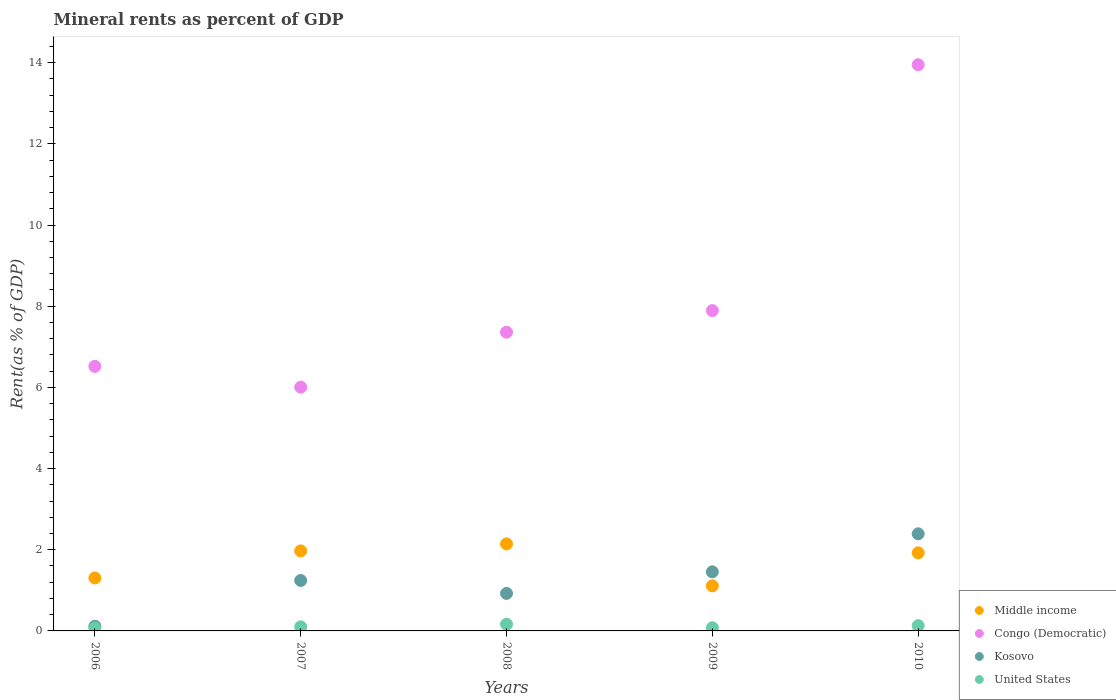What is the mineral rent in Middle income in 2007?
Ensure brevity in your answer.  1.97. Across all years, what is the maximum mineral rent in Kosovo?
Offer a very short reply. 2.39. Across all years, what is the minimum mineral rent in Middle income?
Make the answer very short. 1.11. In which year was the mineral rent in Kosovo minimum?
Provide a succinct answer. 2006. What is the total mineral rent in Kosovo in the graph?
Offer a very short reply. 6.13. What is the difference between the mineral rent in United States in 2007 and that in 2009?
Offer a terse response. 0.02. What is the difference between the mineral rent in Kosovo in 2006 and the mineral rent in Middle income in 2010?
Your response must be concise. -1.81. What is the average mineral rent in Congo (Democratic) per year?
Ensure brevity in your answer.  8.34. In the year 2006, what is the difference between the mineral rent in Congo (Democratic) and mineral rent in Middle income?
Your response must be concise. 5.21. In how many years, is the mineral rent in United States greater than 2.4 %?
Your answer should be compact. 0. What is the ratio of the mineral rent in Congo (Democratic) in 2006 to that in 2007?
Keep it short and to the point. 1.09. What is the difference between the highest and the second highest mineral rent in Kosovo?
Ensure brevity in your answer.  0.94. What is the difference between the highest and the lowest mineral rent in United States?
Offer a terse response. 0.09. In how many years, is the mineral rent in Congo (Democratic) greater than the average mineral rent in Congo (Democratic) taken over all years?
Keep it short and to the point. 1. Is the sum of the mineral rent in Congo (Democratic) in 2006 and 2010 greater than the maximum mineral rent in United States across all years?
Offer a terse response. Yes. Is it the case that in every year, the sum of the mineral rent in Congo (Democratic) and mineral rent in Kosovo  is greater than the sum of mineral rent in United States and mineral rent in Middle income?
Your response must be concise. Yes. Is it the case that in every year, the sum of the mineral rent in Kosovo and mineral rent in United States  is greater than the mineral rent in Congo (Democratic)?
Provide a short and direct response. No. Is the mineral rent in United States strictly greater than the mineral rent in Middle income over the years?
Keep it short and to the point. No. How many years are there in the graph?
Your response must be concise. 5. What is the difference between two consecutive major ticks on the Y-axis?
Ensure brevity in your answer.  2. Where does the legend appear in the graph?
Your answer should be very brief. Bottom right. How are the legend labels stacked?
Make the answer very short. Vertical. What is the title of the graph?
Give a very brief answer. Mineral rents as percent of GDP. Does "Madagascar" appear as one of the legend labels in the graph?
Provide a succinct answer. No. What is the label or title of the Y-axis?
Make the answer very short. Rent(as % of GDP). What is the Rent(as % of GDP) of Middle income in 2006?
Give a very brief answer. 1.31. What is the Rent(as % of GDP) in Congo (Democratic) in 2006?
Give a very brief answer. 6.52. What is the Rent(as % of GDP) of Kosovo in 2006?
Your answer should be compact. 0.12. What is the Rent(as % of GDP) in United States in 2006?
Keep it short and to the point. 0.07. What is the Rent(as % of GDP) in Middle income in 2007?
Offer a very short reply. 1.97. What is the Rent(as % of GDP) in Congo (Democratic) in 2007?
Provide a short and direct response. 6.01. What is the Rent(as % of GDP) in Kosovo in 2007?
Provide a short and direct response. 1.24. What is the Rent(as % of GDP) in United States in 2007?
Make the answer very short. 0.1. What is the Rent(as % of GDP) in Middle income in 2008?
Provide a short and direct response. 2.14. What is the Rent(as % of GDP) in Congo (Democratic) in 2008?
Keep it short and to the point. 7.36. What is the Rent(as % of GDP) in Kosovo in 2008?
Provide a succinct answer. 0.92. What is the Rent(as % of GDP) in United States in 2008?
Your answer should be compact. 0.17. What is the Rent(as % of GDP) in Middle income in 2009?
Your answer should be very brief. 1.11. What is the Rent(as % of GDP) in Congo (Democratic) in 2009?
Keep it short and to the point. 7.89. What is the Rent(as % of GDP) of Kosovo in 2009?
Your answer should be very brief. 1.46. What is the Rent(as % of GDP) in United States in 2009?
Offer a terse response. 0.08. What is the Rent(as % of GDP) of Middle income in 2010?
Ensure brevity in your answer.  1.92. What is the Rent(as % of GDP) in Congo (Democratic) in 2010?
Your answer should be compact. 13.95. What is the Rent(as % of GDP) of Kosovo in 2010?
Provide a short and direct response. 2.39. What is the Rent(as % of GDP) of United States in 2010?
Offer a terse response. 0.13. Across all years, what is the maximum Rent(as % of GDP) in Middle income?
Give a very brief answer. 2.14. Across all years, what is the maximum Rent(as % of GDP) of Congo (Democratic)?
Your answer should be compact. 13.95. Across all years, what is the maximum Rent(as % of GDP) in Kosovo?
Provide a succinct answer. 2.39. Across all years, what is the maximum Rent(as % of GDP) in United States?
Keep it short and to the point. 0.17. Across all years, what is the minimum Rent(as % of GDP) of Middle income?
Offer a very short reply. 1.11. Across all years, what is the minimum Rent(as % of GDP) in Congo (Democratic)?
Offer a terse response. 6.01. Across all years, what is the minimum Rent(as % of GDP) of Kosovo?
Offer a very short reply. 0.12. Across all years, what is the minimum Rent(as % of GDP) in United States?
Provide a succinct answer. 0.07. What is the total Rent(as % of GDP) of Middle income in the graph?
Provide a short and direct response. 8.46. What is the total Rent(as % of GDP) in Congo (Democratic) in the graph?
Give a very brief answer. 41.72. What is the total Rent(as % of GDP) in Kosovo in the graph?
Provide a succinct answer. 6.13. What is the total Rent(as % of GDP) in United States in the graph?
Provide a succinct answer. 0.55. What is the difference between the Rent(as % of GDP) in Middle income in 2006 and that in 2007?
Keep it short and to the point. -0.67. What is the difference between the Rent(as % of GDP) of Congo (Democratic) in 2006 and that in 2007?
Ensure brevity in your answer.  0.51. What is the difference between the Rent(as % of GDP) in Kosovo in 2006 and that in 2007?
Ensure brevity in your answer.  -1.13. What is the difference between the Rent(as % of GDP) in United States in 2006 and that in 2007?
Offer a very short reply. -0.03. What is the difference between the Rent(as % of GDP) in Middle income in 2006 and that in 2008?
Provide a short and direct response. -0.84. What is the difference between the Rent(as % of GDP) in Congo (Democratic) in 2006 and that in 2008?
Your response must be concise. -0.84. What is the difference between the Rent(as % of GDP) of Kosovo in 2006 and that in 2008?
Keep it short and to the point. -0.81. What is the difference between the Rent(as % of GDP) of United States in 2006 and that in 2008?
Make the answer very short. -0.09. What is the difference between the Rent(as % of GDP) in Middle income in 2006 and that in 2009?
Provide a short and direct response. 0.19. What is the difference between the Rent(as % of GDP) in Congo (Democratic) in 2006 and that in 2009?
Keep it short and to the point. -1.37. What is the difference between the Rent(as % of GDP) in Kosovo in 2006 and that in 2009?
Provide a succinct answer. -1.34. What is the difference between the Rent(as % of GDP) of United States in 2006 and that in 2009?
Your answer should be very brief. -0.01. What is the difference between the Rent(as % of GDP) of Middle income in 2006 and that in 2010?
Ensure brevity in your answer.  -0.62. What is the difference between the Rent(as % of GDP) of Congo (Democratic) in 2006 and that in 2010?
Your response must be concise. -7.43. What is the difference between the Rent(as % of GDP) of Kosovo in 2006 and that in 2010?
Your response must be concise. -2.28. What is the difference between the Rent(as % of GDP) in United States in 2006 and that in 2010?
Provide a short and direct response. -0.06. What is the difference between the Rent(as % of GDP) of Middle income in 2007 and that in 2008?
Offer a very short reply. -0.17. What is the difference between the Rent(as % of GDP) of Congo (Democratic) in 2007 and that in 2008?
Your answer should be compact. -1.35. What is the difference between the Rent(as % of GDP) of Kosovo in 2007 and that in 2008?
Keep it short and to the point. 0.32. What is the difference between the Rent(as % of GDP) in United States in 2007 and that in 2008?
Offer a very short reply. -0.06. What is the difference between the Rent(as % of GDP) of Middle income in 2007 and that in 2009?
Offer a terse response. 0.86. What is the difference between the Rent(as % of GDP) of Congo (Democratic) in 2007 and that in 2009?
Keep it short and to the point. -1.89. What is the difference between the Rent(as % of GDP) of Kosovo in 2007 and that in 2009?
Ensure brevity in your answer.  -0.21. What is the difference between the Rent(as % of GDP) in United States in 2007 and that in 2009?
Offer a very short reply. 0.02. What is the difference between the Rent(as % of GDP) of Middle income in 2007 and that in 2010?
Offer a terse response. 0.05. What is the difference between the Rent(as % of GDP) of Congo (Democratic) in 2007 and that in 2010?
Make the answer very short. -7.94. What is the difference between the Rent(as % of GDP) of Kosovo in 2007 and that in 2010?
Keep it short and to the point. -1.15. What is the difference between the Rent(as % of GDP) of United States in 2007 and that in 2010?
Your answer should be very brief. -0.03. What is the difference between the Rent(as % of GDP) of Middle income in 2008 and that in 2009?
Give a very brief answer. 1.03. What is the difference between the Rent(as % of GDP) in Congo (Democratic) in 2008 and that in 2009?
Offer a very short reply. -0.53. What is the difference between the Rent(as % of GDP) of Kosovo in 2008 and that in 2009?
Your response must be concise. -0.53. What is the difference between the Rent(as % of GDP) in United States in 2008 and that in 2009?
Your answer should be compact. 0.09. What is the difference between the Rent(as % of GDP) in Middle income in 2008 and that in 2010?
Make the answer very short. 0.22. What is the difference between the Rent(as % of GDP) of Congo (Democratic) in 2008 and that in 2010?
Your answer should be very brief. -6.59. What is the difference between the Rent(as % of GDP) of Kosovo in 2008 and that in 2010?
Your response must be concise. -1.47. What is the difference between the Rent(as % of GDP) of United States in 2008 and that in 2010?
Provide a succinct answer. 0.04. What is the difference between the Rent(as % of GDP) in Middle income in 2009 and that in 2010?
Provide a succinct answer. -0.81. What is the difference between the Rent(as % of GDP) in Congo (Democratic) in 2009 and that in 2010?
Your response must be concise. -6.06. What is the difference between the Rent(as % of GDP) in Kosovo in 2009 and that in 2010?
Ensure brevity in your answer.  -0.94. What is the difference between the Rent(as % of GDP) in United States in 2009 and that in 2010?
Ensure brevity in your answer.  -0.05. What is the difference between the Rent(as % of GDP) of Middle income in 2006 and the Rent(as % of GDP) of Congo (Democratic) in 2007?
Keep it short and to the point. -4.7. What is the difference between the Rent(as % of GDP) in Middle income in 2006 and the Rent(as % of GDP) in Kosovo in 2007?
Provide a short and direct response. 0.06. What is the difference between the Rent(as % of GDP) in Middle income in 2006 and the Rent(as % of GDP) in United States in 2007?
Offer a terse response. 1.2. What is the difference between the Rent(as % of GDP) of Congo (Democratic) in 2006 and the Rent(as % of GDP) of Kosovo in 2007?
Provide a short and direct response. 5.27. What is the difference between the Rent(as % of GDP) of Congo (Democratic) in 2006 and the Rent(as % of GDP) of United States in 2007?
Keep it short and to the point. 6.42. What is the difference between the Rent(as % of GDP) of Kosovo in 2006 and the Rent(as % of GDP) of United States in 2007?
Make the answer very short. 0.02. What is the difference between the Rent(as % of GDP) of Middle income in 2006 and the Rent(as % of GDP) of Congo (Democratic) in 2008?
Provide a short and direct response. -6.05. What is the difference between the Rent(as % of GDP) in Middle income in 2006 and the Rent(as % of GDP) in Kosovo in 2008?
Offer a very short reply. 0.38. What is the difference between the Rent(as % of GDP) of Middle income in 2006 and the Rent(as % of GDP) of United States in 2008?
Your answer should be very brief. 1.14. What is the difference between the Rent(as % of GDP) of Congo (Democratic) in 2006 and the Rent(as % of GDP) of Kosovo in 2008?
Give a very brief answer. 5.59. What is the difference between the Rent(as % of GDP) in Congo (Democratic) in 2006 and the Rent(as % of GDP) in United States in 2008?
Provide a succinct answer. 6.35. What is the difference between the Rent(as % of GDP) in Kosovo in 2006 and the Rent(as % of GDP) in United States in 2008?
Offer a terse response. -0.05. What is the difference between the Rent(as % of GDP) of Middle income in 2006 and the Rent(as % of GDP) of Congo (Democratic) in 2009?
Your answer should be very brief. -6.59. What is the difference between the Rent(as % of GDP) in Middle income in 2006 and the Rent(as % of GDP) in Kosovo in 2009?
Offer a terse response. -0.15. What is the difference between the Rent(as % of GDP) in Middle income in 2006 and the Rent(as % of GDP) in United States in 2009?
Your answer should be compact. 1.23. What is the difference between the Rent(as % of GDP) in Congo (Democratic) in 2006 and the Rent(as % of GDP) in Kosovo in 2009?
Keep it short and to the point. 5.06. What is the difference between the Rent(as % of GDP) of Congo (Democratic) in 2006 and the Rent(as % of GDP) of United States in 2009?
Make the answer very short. 6.44. What is the difference between the Rent(as % of GDP) in Kosovo in 2006 and the Rent(as % of GDP) in United States in 2009?
Keep it short and to the point. 0.04. What is the difference between the Rent(as % of GDP) in Middle income in 2006 and the Rent(as % of GDP) in Congo (Democratic) in 2010?
Provide a short and direct response. -12.64. What is the difference between the Rent(as % of GDP) in Middle income in 2006 and the Rent(as % of GDP) in Kosovo in 2010?
Give a very brief answer. -1.09. What is the difference between the Rent(as % of GDP) of Middle income in 2006 and the Rent(as % of GDP) of United States in 2010?
Give a very brief answer. 1.18. What is the difference between the Rent(as % of GDP) in Congo (Democratic) in 2006 and the Rent(as % of GDP) in Kosovo in 2010?
Offer a terse response. 4.12. What is the difference between the Rent(as % of GDP) in Congo (Democratic) in 2006 and the Rent(as % of GDP) in United States in 2010?
Offer a terse response. 6.39. What is the difference between the Rent(as % of GDP) in Kosovo in 2006 and the Rent(as % of GDP) in United States in 2010?
Make the answer very short. -0.01. What is the difference between the Rent(as % of GDP) in Middle income in 2007 and the Rent(as % of GDP) in Congo (Democratic) in 2008?
Make the answer very short. -5.39. What is the difference between the Rent(as % of GDP) in Middle income in 2007 and the Rent(as % of GDP) in Kosovo in 2008?
Your response must be concise. 1.05. What is the difference between the Rent(as % of GDP) of Middle income in 2007 and the Rent(as % of GDP) of United States in 2008?
Ensure brevity in your answer.  1.81. What is the difference between the Rent(as % of GDP) in Congo (Democratic) in 2007 and the Rent(as % of GDP) in Kosovo in 2008?
Provide a short and direct response. 5.08. What is the difference between the Rent(as % of GDP) in Congo (Democratic) in 2007 and the Rent(as % of GDP) in United States in 2008?
Offer a terse response. 5.84. What is the difference between the Rent(as % of GDP) of Kosovo in 2007 and the Rent(as % of GDP) of United States in 2008?
Give a very brief answer. 1.08. What is the difference between the Rent(as % of GDP) in Middle income in 2007 and the Rent(as % of GDP) in Congo (Democratic) in 2009?
Offer a very short reply. -5.92. What is the difference between the Rent(as % of GDP) in Middle income in 2007 and the Rent(as % of GDP) in Kosovo in 2009?
Offer a terse response. 0.52. What is the difference between the Rent(as % of GDP) of Middle income in 2007 and the Rent(as % of GDP) of United States in 2009?
Your response must be concise. 1.89. What is the difference between the Rent(as % of GDP) of Congo (Democratic) in 2007 and the Rent(as % of GDP) of Kosovo in 2009?
Offer a very short reply. 4.55. What is the difference between the Rent(as % of GDP) in Congo (Democratic) in 2007 and the Rent(as % of GDP) in United States in 2009?
Your answer should be compact. 5.93. What is the difference between the Rent(as % of GDP) of Kosovo in 2007 and the Rent(as % of GDP) of United States in 2009?
Ensure brevity in your answer.  1.16. What is the difference between the Rent(as % of GDP) in Middle income in 2007 and the Rent(as % of GDP) in Congo (Democratic) in 2010?
Your answer should be very brief. -11.98. What is the difference between the Rent(as % of GDP) of Middle income in 2007 and the Rent(as % of GDP) of Kosovo in 2010?
Offer a terse response. -0.42. What is the difference between the Rent(as % of GDP) of Middle income in 2007 and the Rent(as % of GDP) of United States in 2010?
Offer a very short reply. 1.84. What is the difference between the Rent(as % of GDP) of Congo (Democratic) in 2007 and the Rent(as % of GDP) of Kosovo in 2010?
Make the answer very short. 3.61. What is the difference between the Rent(as % of GDP) in Congo (Democratic) in 2007 and the Rent(as % of GDP) in United States in 2010?
Give a very brief answer. 5.88. What is the difference between the Rent(as % of GDP) of Kosovo in 2007 and the Rent(as % of GDP) of United States in 2010?
Offer a terse response. 1.11. What is the difference between the Rent(as % of GDP) of Middle income in 2008 and the Rent(as % of GDP) of Congo (Democratic) in 2009?
Make the answer very short. -5.75. What is the difference between the Rent(as % of GDP) in Middle income in 2008 and the Rent(as % of GDP) in Kosovo in 2009?
Offer a very short reply. 0.69. What is the difference between the Rent(as % of GDP) of Middle income in 2008 and the Rent(as % of GDP) of United States in 2009?
Provide a succinct answer. 2.07. What is the difference between the Rent(as % of GDP) of Congo (Democratic) in 2008 and the Rent(as % of GDP) of Kosovo in 2009?
Your answer should be compact. 5.9. What is the difference between the Rent(as % of GDP) of Congo (Democratic) in 2008 and the Rent(as % of GDP) of United States in 2009?
Offer a terse response. 7.28. What is the difference between the Rent(as % of GDP) in Kosovo in 2008 and the Rent(as % of GDP) in United States in 2009?
Provide a short and direct response. 0.85. What is the difference between the Rent(as % of GDP) of Middle income in 2008 and the Rent(as % of GDP) of Congo (Democratic) in 2010?
Your answer should be compact. -11.8. What is the difference between the Rent(as % of GDP) of Middle income in 2008 and the Rent(as % of GDP) of Kosovo in 2010?
Ensure brevity in your answer.  -0.25. What is the difference between the Rent(as % of GDP) of Middle income in 2008 and the Rent(as % of GDP) of United States in 2010?
Provide a succinct answer. 2.02. What is the difference between the Rent(as % of GDP) in Congo (Democratic) in 2008 and the Rent(as % of GDP) in Kosovo in 2010?
Offer a very short reply. 4.97. What is the difference between the Rent(as % of GDP) in Congo (Democratic) in 2008 and the Rent(as % of GDP) in United States in 2010?
Give a very brief answer. 7.23. What is the difference between the Rent(as % of GDP) of Kosovo in 2008 and the Rent(as % of GDP) of United States in 2010?
Give a very brief answer. 0.79. What is the difference between the Rent(as % of GDP) in Middle income in 2009 and the Rent(as % of GDP) in Congo (Democratic) in 2010?
Offer a very short reply. -12.84. What is the difference between the Rent(as % of GDP) in Middle income in 2009 and the Rent(as % of GDP) in Kosovo in 2010?
Provide a short and direct response. -1.28. What is the difference between the Rent(as % of GDP) in Middle income in 2009 and the Rent(as % of GDP) in United States in 2010?
Offer a very short reply. 0.98. What is the difference between the Rent(as % of GDP) in Congo (Democratic) in 2009 and the Rent(as % of GDP) in Kosovo in 2010?
Ensure brevity in your answer.  5.5. What is the difference between the Rent(as % of GDP) in Congo (Democratic) in 2009 and the Rent(as % of GDP) in United States in 2010?
Keep it short and to the point. 7.76. What is the difference between the Rent(as % of GDP) in Kosovo in 2009 and the Rent(as % of GDP) in United States in 2010?
Make the answer very short. 1.33. What is the average Rent(as % of GDP) of Middle income per year?
Provide a short and direct response. 1.69. What is the average Rent(as % of GDP) of Congo (Democratic) per year?
Your answer should be compact. 8.34. What is the average Rent(as % of GDP) of Kosovo per year?
Ensure brevity in your answer.  1.23. What is the average Rent(as % of GDP) in United States per year?
Your response must be concise. 0.11. In the year 2006, what is the difference between the Rent(as % of GDP) in Middle income and Rent(as % of GDP) in Congo (Democratic)?
Make the answer very short. -5.21. In the year 2006, what is the difference between the Rent(as % of GDP) of Middle income and Rent(as % of GDP) of Kosovo?
Keep it short and to the point. 1.19. In the year 2006, what is the difference between the Rent(as % of GDP) in Middle income and Rent(as % of GDP) in United States?
Your answer should be compact. 1.23. In the year 2006, what is the difference between the Rent(as % of GDP) of Congo (Democratic) and Rent(as % of GDP) of Kosovo?
Offer a very short reply. 6.4. In the year 2006, what is the difference between the Rent(as % of GDP) in Congo (Democratic) and Rent(as % of GDP) in United States?
Ensure brevity in your answer.  6.44. In the year 2006, what is the difference between the Rent(as % of GDP) of Kosovo and Rent(as % of GDP) of United States?
Offer a terse response. 0.04. In the year 2007, what is the difference between the Rent(as % of GDP) of Middle income and Rent(as % of GDP) of Congo (Democratic)?
Keep it short and to the point. -4.03. In the year 2007, what is the difference between the Rent(as % of GDP) of Middle income and Rent(as % of GDP) of Kosovo?
Make the answer very short. 0.73. In the year 2007, what is the difference between the Rent(as % of GDP) in Middle income and Rent(as % of GDP) in United States?
Provide a succinct answer. 1.87. In the year 2007, what is the difference between the Rent(as % of GDP) in Congo (Democratic) and Rent(as % of GDP) in Kosovo?
Your answer should be compact. 4.76. In the year 2007, what is the difference between the Rent(as % of GDP) in Congo (Democratic) and Rent(as % of GDP) in United States?
Provide a short and direct response. 5.9. In the year 2007, what is the difference between the Rent(as % of GDP) of Kosovo and Rent(as % of GDP) of United States?
Offer a very short reply. 1.14. In the year 2008, what is the difference between the Rent(as % of GDP) in Middle income and Rent(as % of GDP) in Congo (Democratic)?
Offer a very short reply. -5.21. In the year 2008, what is the difference between the Rent(as % of GDP) of Middle income and Rent(as % of GDP) of Kosovo?
Your answer should be compact. 1.22. In the year 2008, what is the difference between the Rent(as % of GDP) in Middle income and Rent(as % of GDP) in United States?
Offer a terse response. 1.98. In the year 2008, what is the difference between the Rent(as % of GDP) of Congo (Democratic) and Rent(as % of GDP) of Kosovo?
Offer a terse response. 6.44. In the year 2008, what is the difference between the Rent(as % of GDP) in Congo (Democratic) and Rent(as % of GDP) in United States?
Provide a short and direct response. 7.19. In the year 2008, what is the difference between the Rent(as % of GDP) in Kosovo and Rent(as % of GDP) in United States?
Provide a short and direct response. 0.76. In the year 2009, what is the difference between the Rent(as % of GDP) in Middle income and Rent(as % of GDP) in Congo (Democratic)?
Your answer should be very brief. -6.78. In the year 2009, what is the difference between the Rent(as % of GDP) of Middle income and Rent(as % of GDP) of Kosovo?
Your response must be concise. -0.34. In the year 2009, what is the difference between the Rent(as % of GDP) of Middle income and Rent(as % of GDP) of United States?
Give a very brief answer. 1.03. In the year 2009, what is the difference between the Rent(as % of GDP) of Congo (Democratic) and Rent(as % of GDP) of Kosovo?
Give a very brief answer. 6.44. In the year 2009, what is the difference between the Rent(as % of GDP) of Congo (Democratic) and Rent(as % of GDP) of United States?
Give a very brief answer. 7.81. In the year 2009, what is the difference between the Rent(as % of GDP) of Kosovo and Rent(as % of GDP) of United States?
Ensure brevity in your answer.  1.38. In the year 2010, what is the difference between the Rent(as % of GDP) of Middle income and Rent(as % of GDP) of Congo (Democratic)?
Your answer should be very brief. -12.02. In the year 2010, what is the difference between the Rent(as % of GDP) of Middle income and Rent(as % of GDP) of Kosovo?
Make the answer very short. -0.47. In the year 2010, what is the difference between the Rent(as % of GDP) of Middle income and Rent(as % of GDP) of United States?
Give a very brief answer. 1.79. In the year 2010, what is the difference between the Rent(as % of GDP) in Congo (Democratic) and Rent(as % of GDP) in Kosovo?
Keep it short and to the point. 11.56. In the year 2010, what is the difference between the Rent(as % of GDP) in Congo (Democratic) and Rent(as % of GDP) in United States?
Make the answer very short. 13.82. In the year 2010, what is the difference between the Rent(as % of GDP) in Kosovo and Rent(as % of GDP) in United States?
Provide a succinct answer. 2.26. What is the ratio of the Rent(as % of GDP) in Middle income in 2006 to that in 2007?
Give a very brief answer. 0.66. What is the ratio of the Rent(as % of GDP) of Congo (Democratic) in 2006 to that in 2007?
Provide a short and direct response. 1.09. What is the ratio of the Rent(as % of GDP) in Kosovo in 2006 to that in 2007?
Your answer should be very brief. 0.09. What is the ratio of the Rent(as % of GDP) in United States in 2006 to that in 2007?
Your response must be concise. 0.73. What is the ratio of the Rent(as % of GDP) of Middle income in 2006 to that in 2008?
Keep it short and to the point. 0.61. What is the ratio of the Rent(as % of GDP) of Congo (Democratic) in 2006 to that in 2008?
Provide a succinct answer. 0.89. What is the ratio of the Rent(as % of GDP) of Kosovo in 2006 to that in 2008?
Ensure brevity in your answer.  0.13. What is the ratio of the Rent(as % of GDP) of United States in 2006 to that in 2008?
Provide a short and direct response. 0.44. What is the ratio of the Rent(as % of GDP) of Middle income in 2006 to that in 2009?
Give a very brief answer. 1.17. What is the ratio of the Rent(as % of GDP) in Congo (Democratic) in 2006 to that in 2009?
Offer a terse response. 0.83. What is the ratio of the Rent(as % of GDP) in Kosovo in 2006 to that in 2009?
Your response must be concise. 0.08. What is the ratio of the Rent(as % of GDP) in United States in 2006 to that in 2009?
Make the answer very short. 0.94. What is the ratio of the Rent(as % of GDP) in Middle income in 2006 to that in 2010?
Ensure brevity in your answer.  0.68. What is the ratio of the Rent(as % of GDP) of Congo (Democratic) in 2006 to that in 2010?
Your answer should be compact. 0.47. What is the ratio of the Rent(as % of GDP) in Kosovo in 2006 to that in 2010?
Your answer should be very brief. 0.05. What is the ratio of the Rent(as % of GDP) of United States in 2006 to that in 2010?
Your answer should be compact. 0.57. What is the ratio of the Rent(as % of GDP) of Middle income in 2007 to that in 2008?
Your answer should be compact. 0.92. What is the ratio of the Rent(as % of GDP) of Congo (Democratic) in 2007 to that in 2008?
Offer a terse response. 0.82. What is the ratio of the Rent(as % of GDP) in Kosovo in 2007 to that in 2008?
Keep it short and to the point. 1.34. What is the ratio of the Rent(as % of GDP) of United States in 2007 to that in 2008?
Make the answer very short. 0.61. What is the ratio of the Rent(as % of GDP) of Middle income in 2007 to that in 2009?
Your response must be concise. 1.77. What is the ratio of the Rent(as % of GDP) of Congo (Democratic) in 2007 to that in 2009?
Provide a short and direct response. 0.76. What is the ratio of the Rent(as % of GDP) of Kosovo in 2007 to that in 2009?
Provide a short and direct response. 0.85. What is the ratio of the Rent(as % of GDP) in United States in 2007 to that in 2009?
Give a very brief answer. 1.29. What is the ratio of the Rent(as % of GDP) of Middle income in 2007 to that in 2010?
Offer a terse response. 1.02. What is the ratio of the Rent(as % of GDP) in Congo (Democratic) in 2007 to that in 2010?
Offer a very short reply. 0.43. What is the ratio of the Rent(as % of GDP) of Kosovo in 2007 to that in 2010?
Offer a very short reply. 0.52. What is the ratio of the Rent(as % of GDP) in United States in 2007 to that in 2010?
Provide a succinct answer. 0.78. What is the ratio of the Rent(as % of GDP) in Middle income in 2008 to that in 2009?
Give a very brief answer. 1.93. What is the ratio of the Rent(as % of GDP) of Congo (Democratic) in 2008 to that in 2009?
Ensure brevity in your answer.  0.93. What is the ratio of the Rent(as % of GDP) of Kosovo in 2008 to that in 2009?
Make the answer very short. 0.63. What is the ratio of the Rent(as % of GDP) in United States in 2008 to that in 2009?
Give a very brief answer. 2.11. What is the ratio of the Rent(as % of GDP) of Middle income in 2008 to that in 2010?
Offer a terse response. 1.11. What is the ratio of the Rent(as % of GDP) of Congo (Democratic) in 2008 to that in 2010?
Ensure brevity in your answer.  0.53. What is the ratio of the Rent(as % of GDP) of Kosovo in 2008 to that in 2010?
Ensure brevity in your answer.  0.39. What is the ratio of the Rent(as % of GDP) of United States in 2008 to that in 2010?
Ensure brevity in your answer.  1.28. What is the ratio of the Rent(as % of GDP) in Middle income in 2009 to that in 2010?
Make the answer very short. 0.58. What is the ratio of the Rent(as % of GDP) in Congo (Democratic) in 2009 to that in 2010?
Keep it short and to the point. 0.57. What is the ratio of the Rent(as % of GDP) of Kosovo in 2009 to that in 2010?
Offer a very short reply. 0.61. What is the ratio of the Rent(as % of GDP) of United States in 2009 to that in 2010?
Give a very brief answer. 0.61. What is the difference between the highest and the second highest Rent(as % of GDP) in Middle income?
Make the answer very short. 0.17. What is the difference between the highest and the second highest Rent(as % of GDP) in Congo (Democratic)?
Ensure brevity in your answer.  6.06. What is the difference between the highest and the second highest Rent(as % of GDP) of Kosovo?
Keep it short and to the point. 0.94. What is the difference between the highest and the second highest Rent(as % of GDP) in United States?
Your response must be concise. 0.04. What is the difference between the highest and the lowest Rent(as % of GDP) of Middle income?
Offer a very short reply. 1.03. What is the difference between the highest and the lowest Rent(as % of GDP) in Congo (Democratic)?
Give a very brief answer. 7.94. What is the difference between the highest and the lowest Rent(as % of GDP) in Kosovo?
Provide a short and direct response. 2.28. What is the difference between the highest and the lowest Rent(as % of GDP) in United States?
Ensure brevity in your answer.  0.09. 